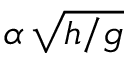<formula> <loc_0><loc_0><loc_500><loc_500>\alpha \, \sqrt { h / g }</formula> 